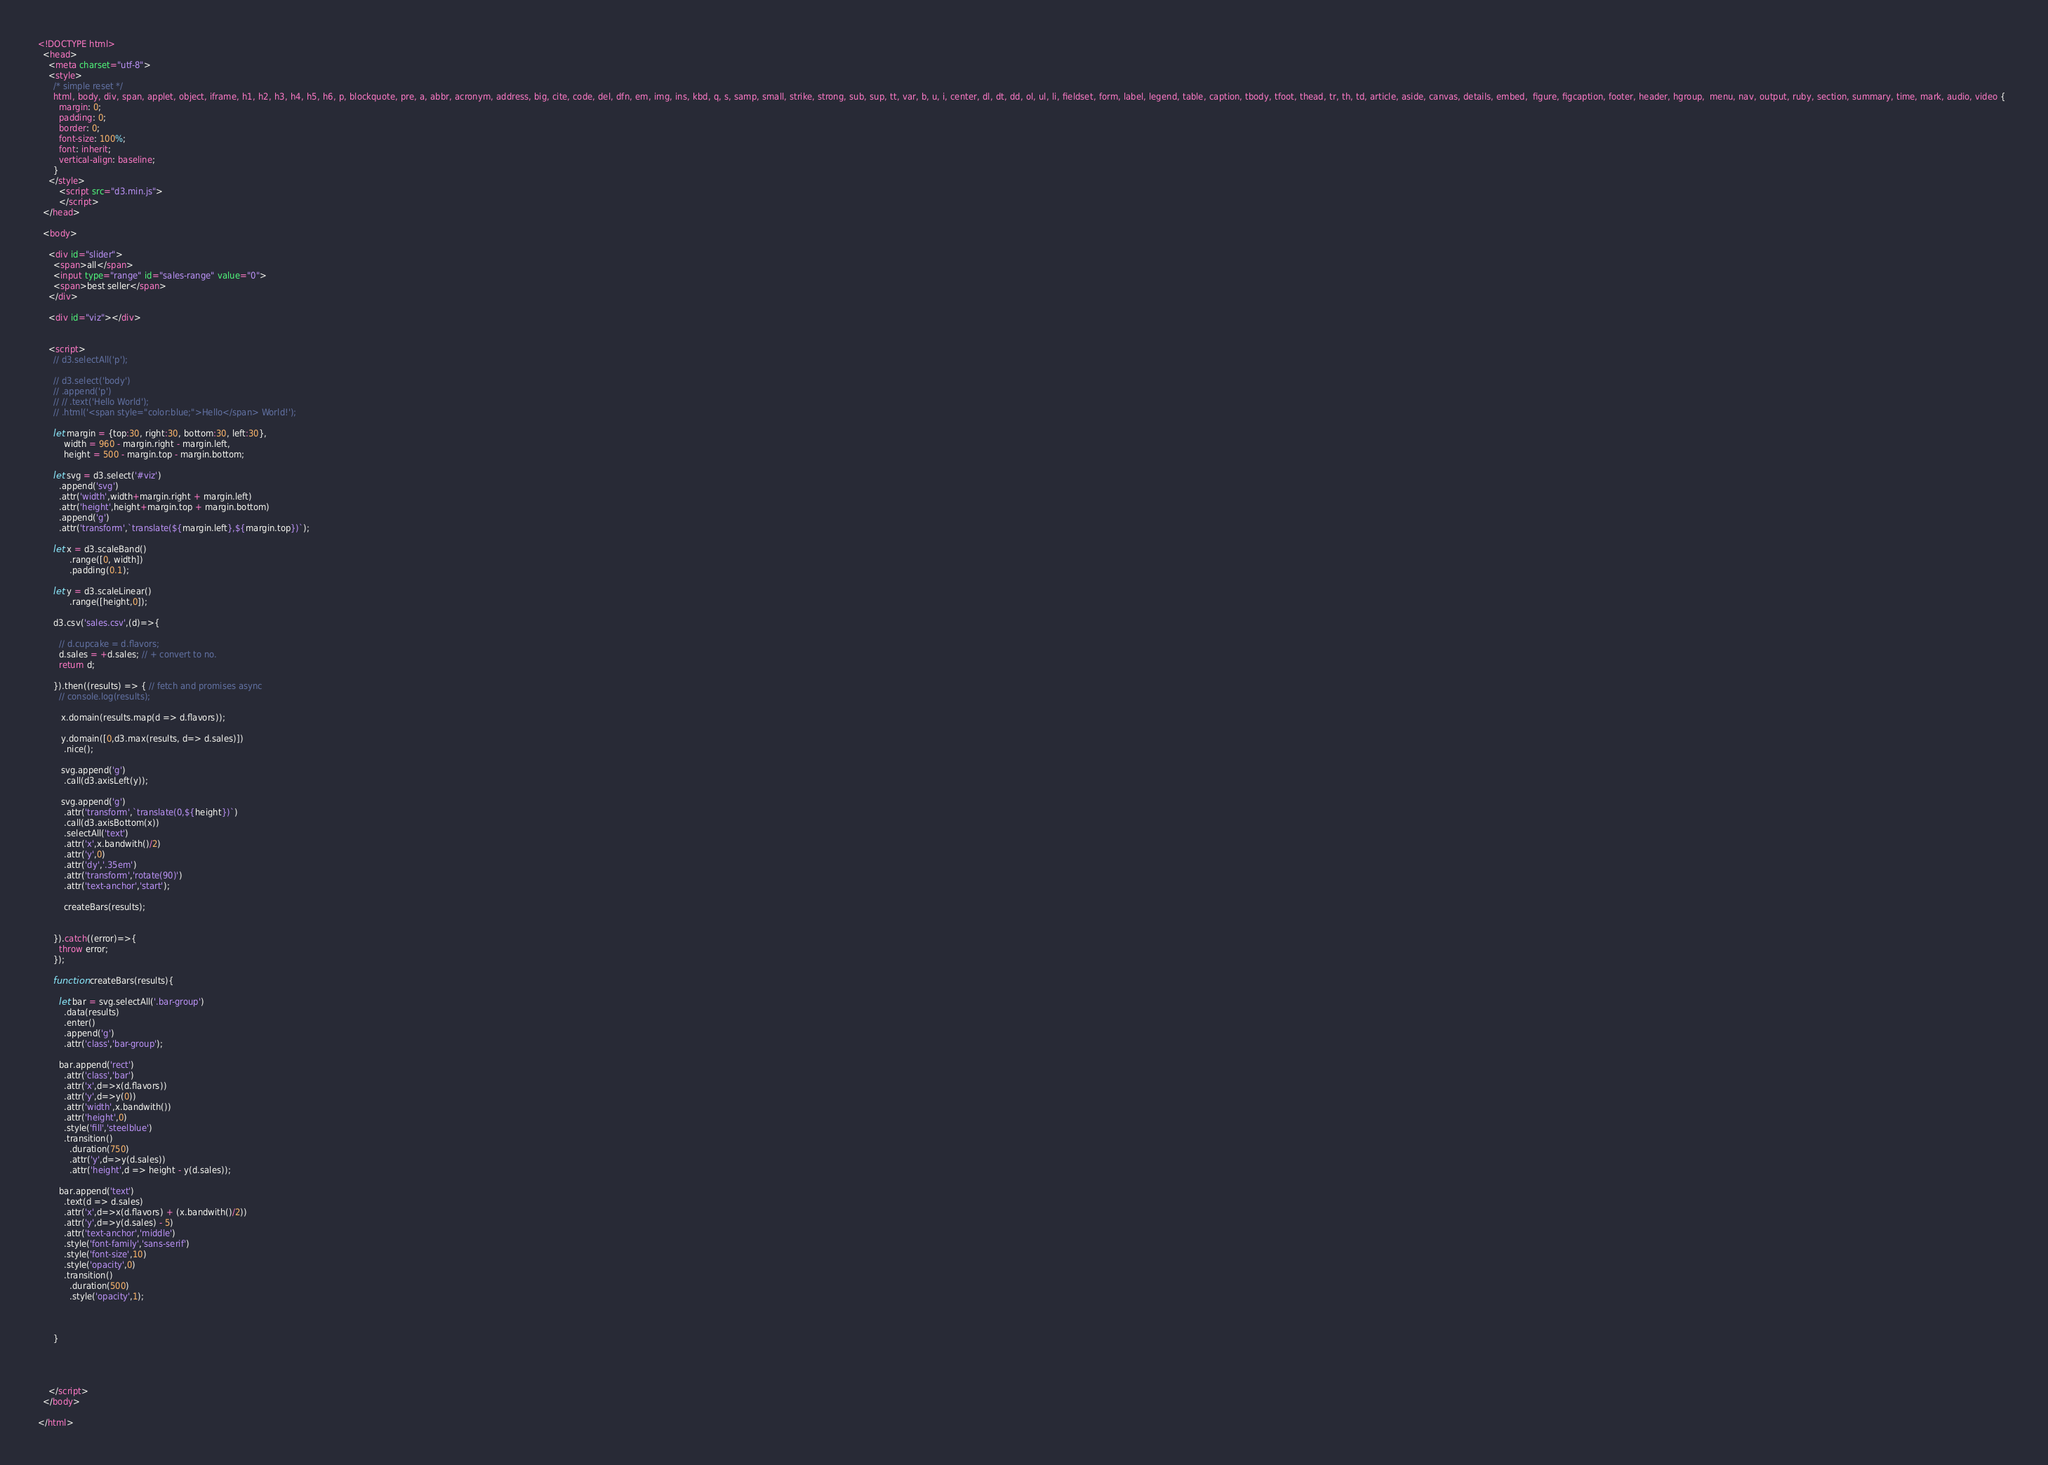Convert code to text. <code><loc_0><loc_0><loc_500><loc_500><_HTML_><!DOCTYPE html>
  <head>
    <meta charset="utf-8">
    <style>
      /* simple reset */
      html, body, div, span, applet, object, iframe, h1, h2, h3, h4, h5, h6, p, blockquote, pre, a, abbr, acronym, address, big, cite, code, del, dfn, em, img, ins, kbd, q, s, samp, small, strike, strong, sub, sup, tt, var, b, u, i, center, dl, dt, dd, ol, ul, li, fieldset, form, label, legend, table, caption, tbody, tfoot, thead, tr, th, td, article, aside, canvas, details, embed,  figure, figcaption, footer, header, hgroup,  menu, nav, output, ruby, section, summary, time, mark, audio, video {  
        margin: 0;  
        padding: 0;  
        border: 0;  
        font-size: 100%;  
        font: inherit;  
        vertical-align: baseline; 
      }
    </style>
        <script src="d3.min.js">
        </script>
  </head>

  <body>

    <div id="slider">
      <span>all</span>
      <input type="range" id="sales-range" value="0">
      <span>best seller</span>
    </div>

    <div id="viz"></div>


    <script>
      // d3.selectAll('p');

      // d3.select('body')
      // .append('p')
      // // .text('Hello World');
      // .html('<span style="color:blue;">Hello</span> World!');
      
      let margin = {top:30, right:30, bottom:30, left:30},
          width = 960 - margin.right - margin.left,
          height = 500 - margin.top - margin.bottom;

      let svg = d3.select('#viz')
        .append('svg')
        .attr('width',width+margin.right + margin.left)
        .attr('height',height+margin.top + margin.bottom)
        .append('g')
        .attr('transform',`translate(${margin.left},${margin.top})`);

      let x = d3.scaleBand()
            .range([0, width])
            .padding(0.1);
      
      let y = d3.scaleLinear()
            .range([height,0]);

      d3.csv('sales.csv',(d)=>{

        // d.cupcake = d.flavors;
        d.sales = +d.sales; // + convert to no.
        return d;

      }).then((results) => { // fetch and promises async 
        // console.log(results);

         x.domain(results.map(d => d.flavors));

         y.domain([0,d3.max(results, d=> d.sales)])
          .nice();

         svg.append('g')
          .call(d3.axisLeft(y));

         svg.append('g')
          .attr('transform',`translate(0,${height})`)
          .call(d3.axisBottom(x))
          .selectAll('text')
          .attr('x',x.bandwith()/2)
          .attr('y',0)
          .attr('dy','.35em')
          .attr('transform','rotate(90)')
          .attr('text-anchor','start');

          createBars(results);


      }).catch((error)=>{
        throw error;
      });

      function createBars(results){

        let bar = svg.selectAll('.bar-group')
          .data(results)
          .enter()
          .append('g')
          .attr('class','bar-group');

        bar.append('rect')
          .attr('class','bar')
          .attr('x',d=>x(d.flavors))
          .attr('y',d=>y(0))
          .attr('width',x.bandwith())
          .attr('height',0)
          .style('fill','steelblue')
          .transition()
            .duration(750)
            .attr('y',d=>y(d.sales))
            .attr('height',d => height - y(d.sales));  

        bar.append('text')
          .text(d => d.sales)
          .attr('x',d=>x(d.flavors) + (x.bandwith()/2))
          .attr('y',d=>y(d.sales) - 5)
          .attr('text-anchor','middle')
          .style('font-family','sans-serif')
          .style('font-size',10)
          .style('opacity',0)
          .transition()
            .duration(500)
            .style('opacity',1);



      }




    </script>
  </body>

</html></code> 